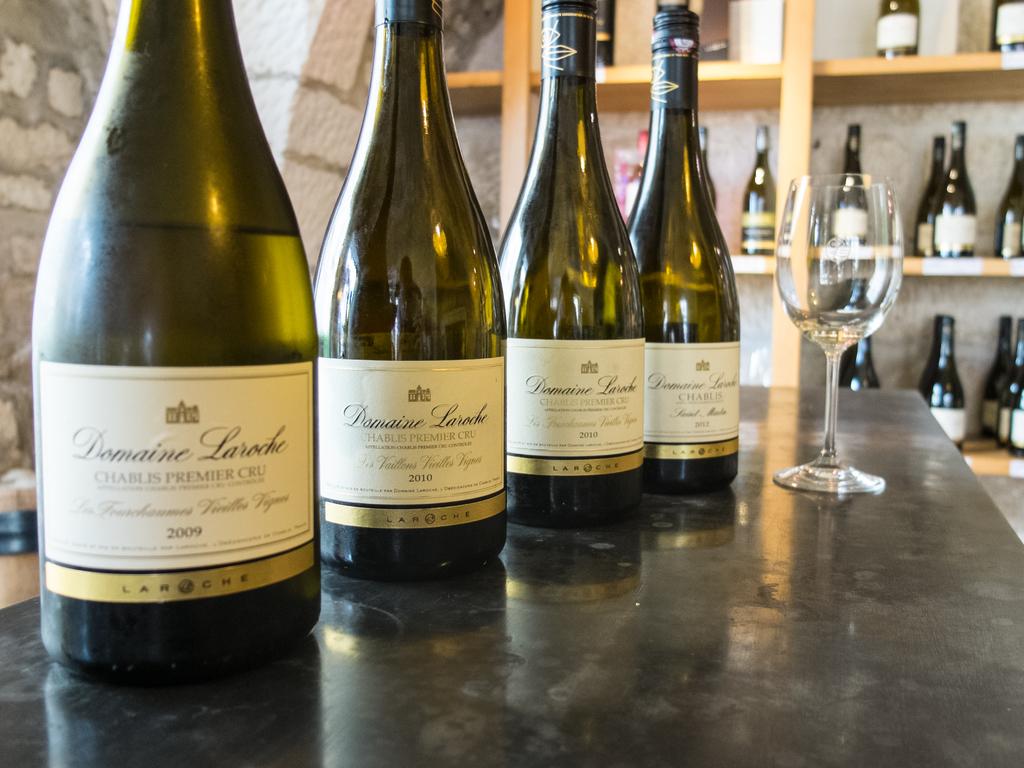When was the front bottle made?
Your response must be concise. 2009. 